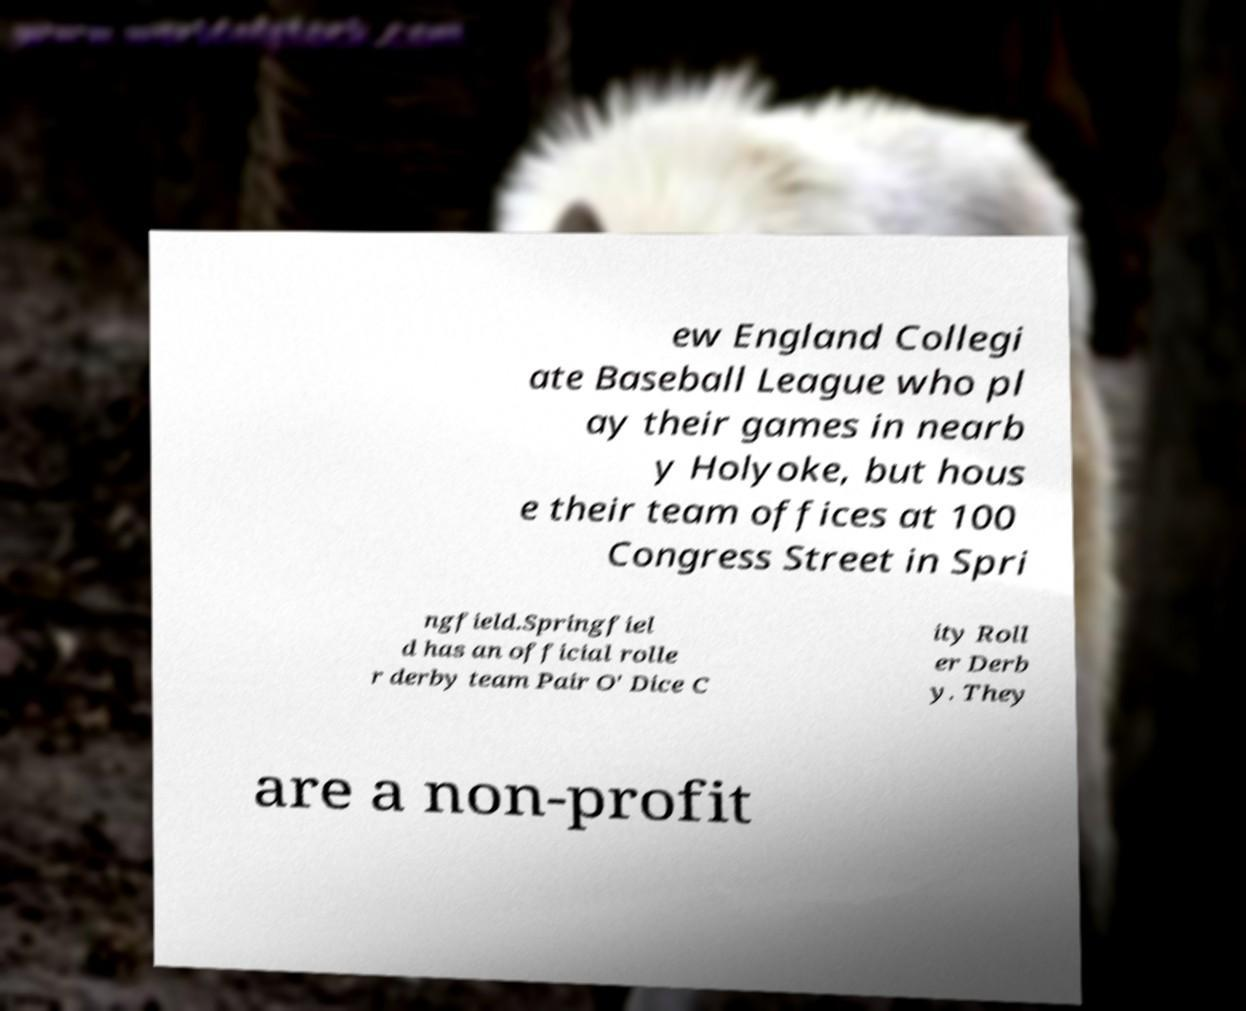Can you read and provide the text displayed in the image?This photo seems to have some interesting text. Can you extract and type it out for me? ew England Collegi ate Baseball League who pl ay their games in nearb y Holyoke, but hous e their team offices at 100 Congress Street in Spri ngfield.Springfiel d has an official rolle r derby team Pair O' Dice C ity Roll er Derb y. They are a non-profit 